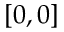<formula> <loc_0><loc_0><loc_500><loc_500>[ 0 , 0 ]</formula> 